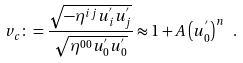<formula> <loc_0><loc_0><loc_500><loc_500>v _ { c } \colon = \frac { \sqrt { - \eta ^ { i j } u ^ { ^ { \prime } } _ { i } u ^ { ^ { \prime } } _ { j } } } { \sqrt { \eta ^ { 0 0 } u ^ { ^ { \prime } } _ { 0 } u ^ { ^ { \prime } } _ { 0 } } } \approx 1 + A \left ( u ^ { ^ { \prime } } _ { 0 } \right ) ^ { n } \ .</formula> 